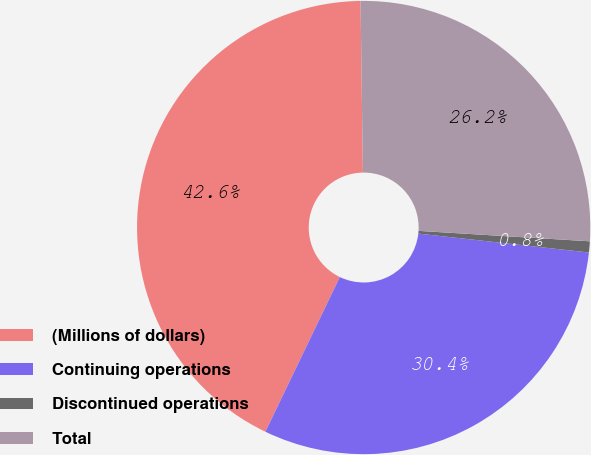Convert chart. <chart><loc_0><loc_0><loc_500><loc_500><pie_chart><fcel>(Millions of dollars)<fcel>Continuing operations<fcel>Discontinued operations<fcel>Total<nl><fcel>42.64%<fcel>30.38%<fcel>0.79%<fcel>26.19%<nl></chart> 